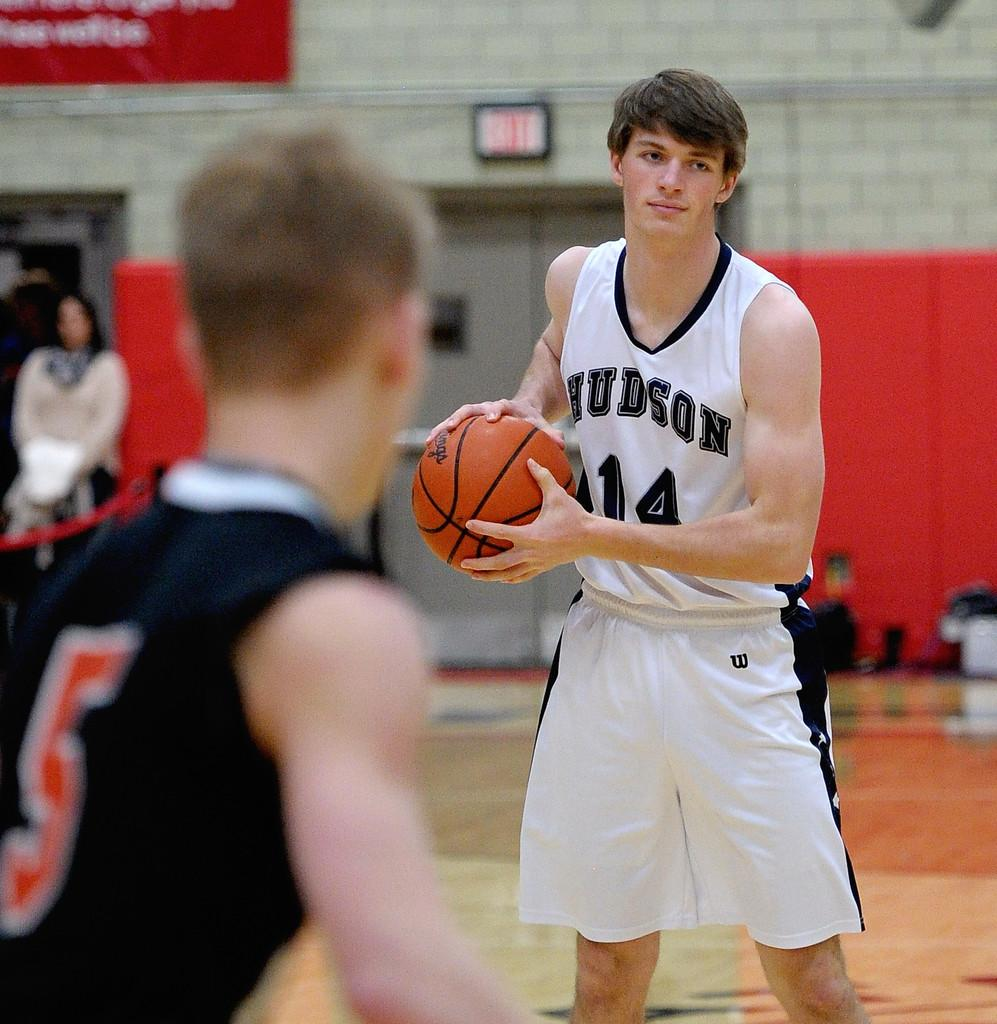<image>
Summarize the visual content of the image. a player that has the team name Hudson on his jersey 